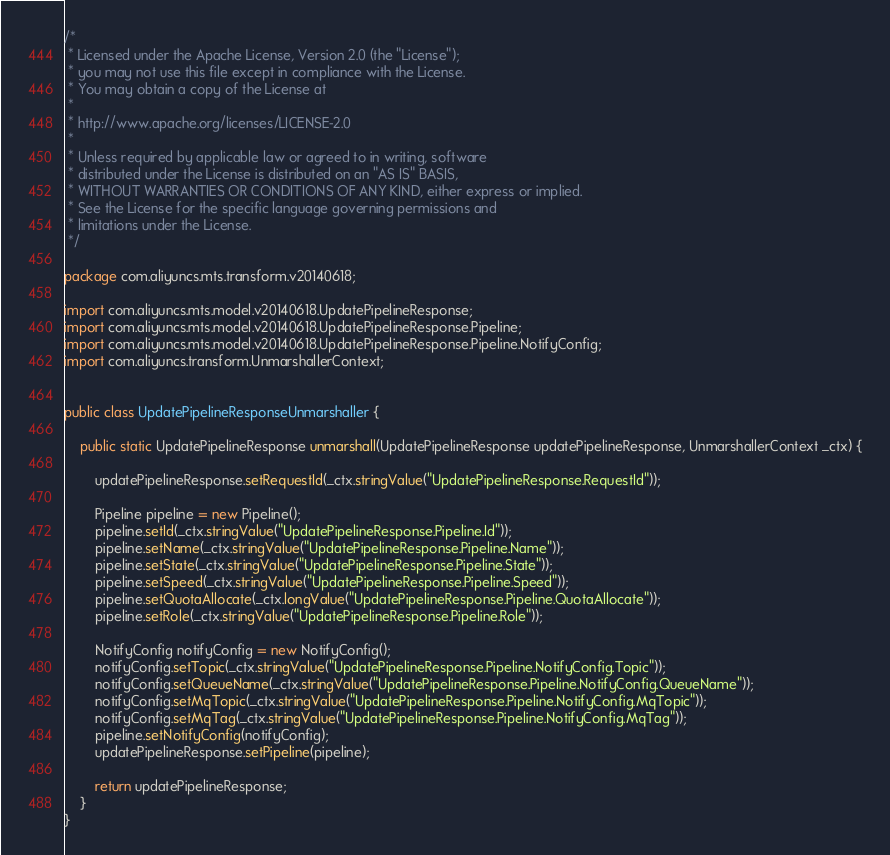<code> <loc_0><loc_0><loc_500><loc_500><_Java_>/*
 * Licensed under the Apache License, Version 2.0 (the "License");
 * you may not use this file except in compliance with the License.
 * You may obtain a copy of the License at
 *
 * http://www.apache.org/licenses/LICENSE-2.0
 *
 * Unless required by applicable law or agreed to in writing, software
 * distributed under the License is distributed on an "AS IS" BASIS,
 * WITHOUT WARRANTIES OR CONDITIONS OF ANY KIND, either express or implied.
 * See the License for the specific language governing permissions and
 * limitations under the License.
 */

package com.aliyuncs.mts.transform.v20140618;

import com.aliyuncs.mts.model.v20140618.UpdatePipelineResponse;
import com.aliyuncs.mts.model.v20140618.UpdatePipelineResponse.Pipeline;
import com.aliyuncs.mts.model.v20140618.UpdatePipelineResponse.Pipeline.NotifyConfig;
import com.aliyuncs.transform.UnmarshallerContext;


public class UpdatePipelineResponseUnmarshaller {

	public static UpdatePipelineResponse unmarshall(UpdatePipelineResponse updatePipelineResponse, UnmarshallerContext _ctx) {
		
		updatePipelineResponse.setRequestId(_ctx.stringValue("UpdatePipelineResponse.RequestId"));

		Pipeline pipeline = new Pipeline();
		pipeline.setId(_ctx.stringValue("UpdatePipelineResponse.Pipeline.Id"));
		pipeline.setName(_ctx.stringValue("UpdatePipelineResponse.Pipeline.Name"));
		pipeline.setState(_ctx.stringValue("UpdatePipelineResponse.Pipeline.State"));
		pipeline.setSpeed(_ctx.stringValue("UpdatePipelineResponse.Pipeline.Speed"));
		pipeline.setQuotaAllocate(_ctx.longValue("UpdatePipelineResponse.Pipeline.QuotaAllocate"));
		pipeline.setRole(_ctx.stringValue("UpdatePipelineResponse.Pipeline.Role"));

		NotifyConfig notifyConfig = new NotifyConfig();
		notifyConfig.setTopic(_ctx.stringValue("UpdatePipelineResponse.Pipeline.NotifyConfig.Topic"));
		notifyConfig.setQueueName(_ctx.stringValue("UpdatePipelineResponse.Pipeline.NotifyConfig.QueueName"));
		notifyConfig.setMqTopic(_ctx.stringValue("UpdatePipelineResponse.Pipeline.NotifyConfig.MqTopic"));
		notifyConfig.setMqTag(_ctx.stringValue("UpdatePipelineResponse.Pipeline.NotifyConfig.MqTag"));
		pipeline.setNotifyConfig(notifyConfig);
		updatePipelineResponse.setPipeline(pipeline);
	 
	 	return updatePipelineResponse;
	}
}</code> 